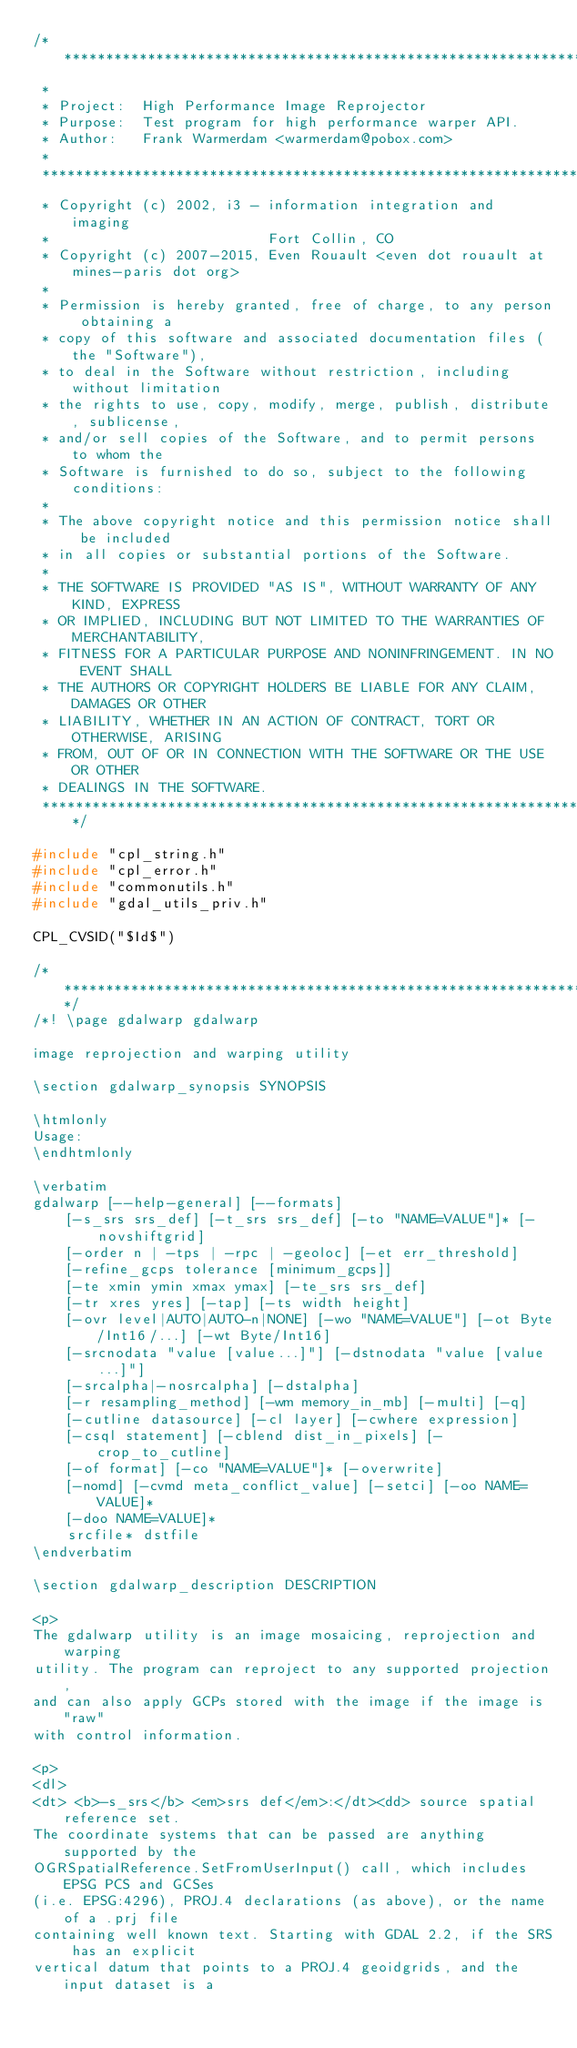<code> <loc_0><loc_0><loc_500><loc_500><_C++_>/******************************************************************************
 *
 * Project:  High Performance Image Reprojector
 * Purpose:  Test program for high performance warper API.
 * Author:   Frank Warmerdam <warmerdam@pobox.com>
 *
 ******************************************************************************
 * Copyright (c) 2002, i3 - information integration and imaging
 *                          Fort Collin, CO
 * Copyright (c) 2007-2015, Even Rouault <even dot rouault at mines-paris dot org>
 *
 * Permission is hereby granted, free of charge, to any person obtaining a
 * copy of this software and associated documentation files (the "Software"),
 * to deal in the Software without restriction, including without limitation
 * the rights to use, copy, modify, merge, publish, distribute, sublicense,
 * and/or sell copies of the Software, and to permit persons to whom the
 * Software is furnished to do so, subject to the following conditions:
 *
 * The above copyright notice and this permission notice shall be included
 * in all copies or substantial portions of the Software.
 *
 * THE SOFTWARE IS PROVIDED "AS IS", WITHOUT WARRANTY OF ANY KIND, EXPRESS
 * OR IMPLIED, INCLUDING BUT NOT LIMITED TO THE WARRANTIES OF MERCHANTABILITY,
 * FITNESS FOR A PARTICULAR PURPOSE AND NONINFRINGEMENT. IN NO EVENT SHALL
 * THE AUTHORS OR COPYRIGHT HOLDERS BE LIABLE FOR ANY CLAIM, DAMAGES OR OTHER
 * LIABILITY, WHETHER IN AN ACTION OF CONTRACT, TORT OR OTHERWISE, ARISING
 * FROM, OUT OF OR IN CONNECTION WITH THE SOFTWARE OR THE USE OR OTHER
 * DEALINGS IN THE SOFTWARE.
 ****************************************************************************/

#include "cpl_string.h"
#include "cpl_error.h"
#include "commonutils.h"
#include "gdal_utils_priv.h"

CPL_CVSID("$Id$")

/******************************************************************************/
/*! \page gdalwarp gdalwarp

image reprojection and warping utility

\section gdalwarp_synopsis SYNOPSIS

\htmlonly
Usage:
\endhtmlonly

\verbatim
gdalwarp [--help-general] [--formats]
    [-s_srs srs_def] [-t_srs srs_def] [-to "NAME=VALUE"]* [-novshiftgrid]
    [-order n | -tps | -rpc | -geoloc] [-et err_threshold]
    [-refine_gcps tolerance [minimum_gcps]]
    [-te xmin ymin xmax ymax] [-te_srs srs_def]
    [-tr xres yres] [-tap] [-ts width height]
    [-ovr level|AUTO|AUTO-n|NONE] [-wo "NAME=VALUE"] [-ot Byte/Int16/...] [-wt Byte/Int16]
    [-srcnodata "value [value...]"] [-dstnodata "value [value...]"]
    [-srcalpha|-nosrcalpha] [-dstalpha]
    [-r resampling_method] [-wm memory_in_mb] [-multi] [-q]
    [-cutline datasource] [-cl layer] [-cwhere expression]
    [-csql statement] [-cblend dist_in_pixels] [-crop_to_cutline]
    [-of format] [-co "NAME=VALUE"]* [-overwrite]
    [-nomd] [-cvmd meta_conflict_value] [-setci] [-oo NAME=VALUE]*
    [-doo NAME=VALUE]*
    srcfile* dstfile
\endverbatim

\section gdalwarp_description DESCRIPTION

<p>
The gdalwarp utility is an image mosaicing, reprojection and warping
utility. The program can reproject to any supported projection,
and can also apply GCPs stored with the image if the image is "raw"
with control information.

<p>
<dl>
<dt> <b>-s_srs</b> <em>srs def</em>:</dt><dd> source spatial reference set.
The coordinate systems that can be passed are anything supported by the
OGRSpatialReference.SetFromUserInput() call, which includes EPSG PCS and GCSes
(i.e. EPSG:4296), PROJ.4 declarations (as above), or the name of a .prj file
containing well known text. Starting with GDAL 2.2, if the SRS has an explicit
vertical datum that points to a PROJ.4 geoidgrids, and the input dataset is a</code> 